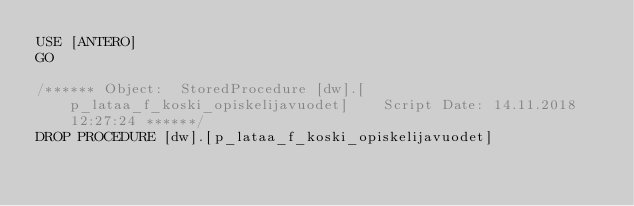<code> <loc_0><loc_0><loc_500><loc_500><_SQL_>USE [ANTERO]
GO

/****** Object:  StoredProcedure [dw].[p_lataa_f_koski_opiskelijavuodet]    Script Date: 14.11.2018 12:27:24 ******/
DROP PROCEDURE [dw].[p_lataa_f_koski_opiskelijavuodet]
</code> 